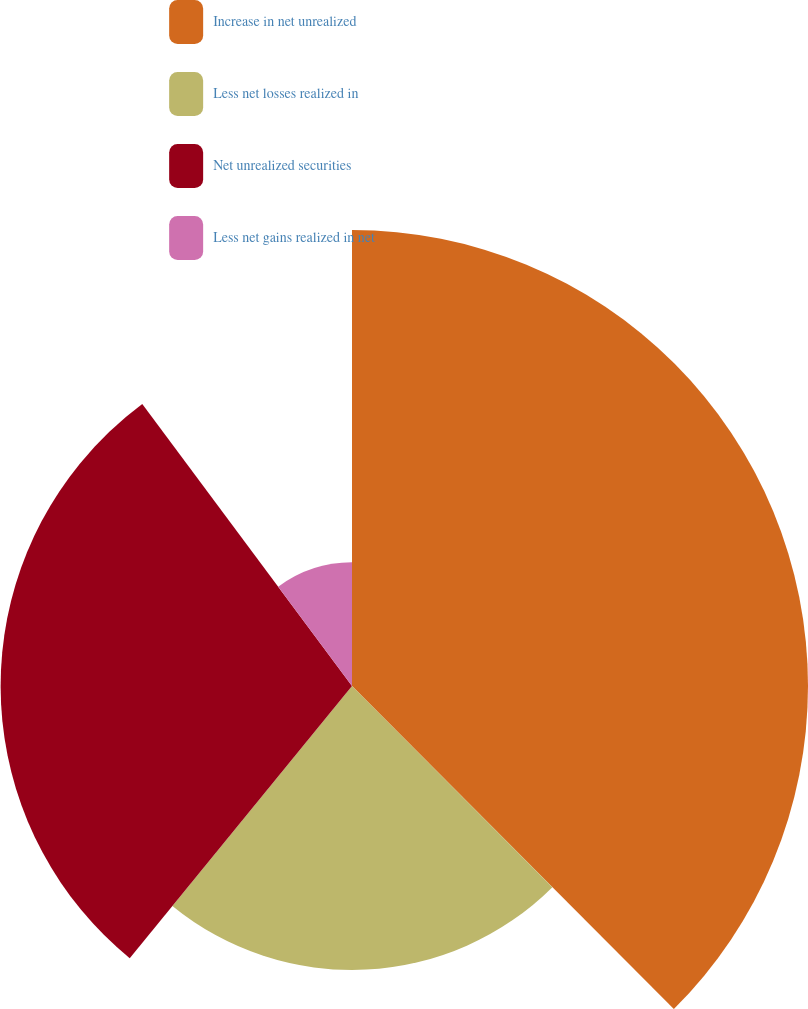Convert chart to OTSL. <chart><loc_0><loc_0><loc_500><loc_500><pie_chart><fcel>Increase in net unrealized<fcel>Less net losses realized in<fcel>Net unrealized securities<fcel>Less net gains realized in net<nl><fcel>37.53%<fcel>23.37%<fcel>28.92%<fcel>10.18%<nl></chart> 